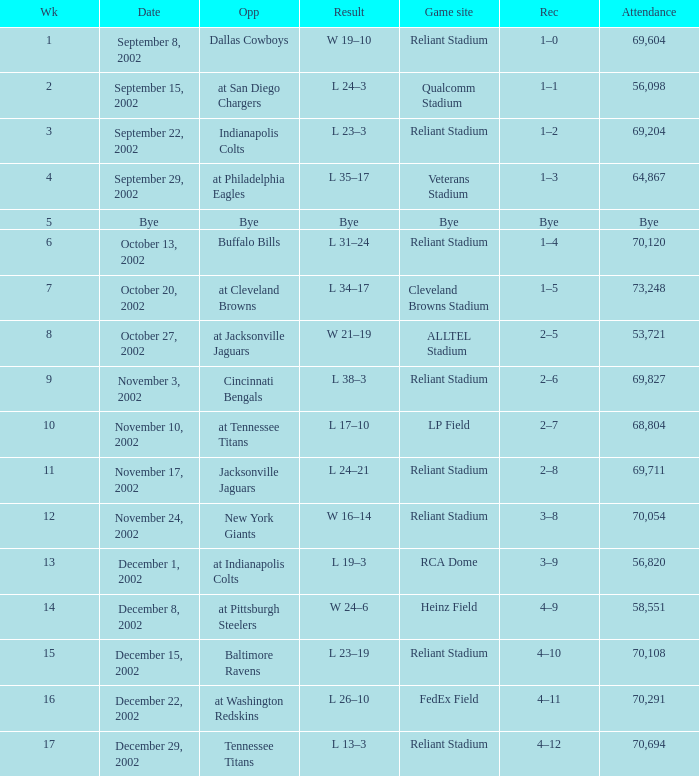What is the earliest week that the Texans played at the Cleveland Browns Stadium? 7.0. Would you mind parsing the complete table? {'header': ['Wk', 'Date', 'Opp', 'Result', 'Game site', 'Rec', 'Attendance'], 'rows': [['1', 'September 8, 2002', 'Dallas Cowboys', 'W 19–10', 'Reliant Stadium', '1–0', '69,604'], ['2', 'September 15, 2002', 'at San Diego Chargers', 'L 24–3', 'Qualcomm Stadium', '1–1', '56,098'], ['3', 'September 22, 2002', 'Indianapolis Colts', 'L 23–3', 'Reliant Stadium', '1–2', '69,204'], ['4', 'September 29, 2002', 'at Philadelphia Eagles', 'L 35–17', 'Veterans Stadium', '1–3', '64,867'], ['5', 'Bye', 'Bye', 'Bye', 'Bye', 'Bye', 'Bye'], ['6', 'October 13, 2002', 'Buffalo Bills', 'L 31–24', 'Reliant Stadium', '1–4', '70,120'], ['7', 'October 20, 2002', 'at Cleveland Browns', 'L 34–17', 'Cleveland Browns Stadium', '1–5', '73,248'], ['8', 'October 27, 2002', 'at Jacksonville Jaguars', 'W 21–19', 'ALLTEL Stadium', '2–5', '53,721'], ['9', 'November 3, 2002', 'Cincinnati Bengals', 'L 38–3', 'Reliant Stadium', '2–6', '69,827'], ['10', 'November 10, 2002', 'at Tennessee Titans', 'L 17–10', 'LP Field', '2–7', '68,804'], ['11', 'November 17, 2002', 'Jacksonville Jaguars', 'L 24–21', 'Reliant Stadium', '2–8', '69,711'], ['12', 'November 24, 2002', 'New York Giants', 'W 16–14', 'Reliant Stadium', '3–8', '70,054'], ['13', 'December 1, 2002', 'at Indianapolis Colts', 'L 19–3', 'RCA Dome', '3–9', '56,820'], ['14', 'December 8, 2002', 'at Pittsburgh Steelers', 'W 24–6', 'Heinz Field', '4–9', '58,551'], ['15', 'December 15, 2002', 'Baltimore Ravens', 'L 23–19', 'Reliant Stadium', '4–10', '70,108'], ['16', 'December 22, 2002', 'at Washington Redskins', 'L 26–10', 'FedEx Field', '4–11', '70,291'], ['17', 'December 29, 2002', 'Tennessee Titans', 'L 13–3', 'Reliant Stadium', '4–12', '70,694']]} 